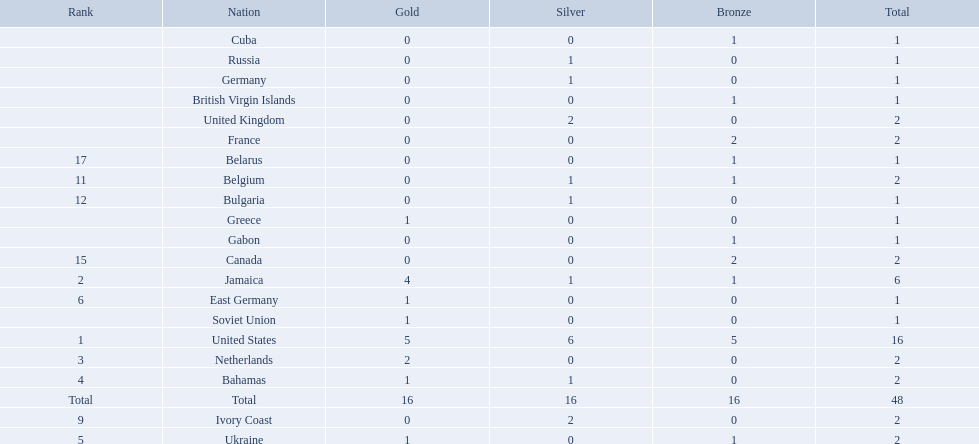What country won the most medals? United States. How many medals did the us win? 16. What is the most medals (after 16) that were won by a country? 6. Which country won 6 medals? Jamaica. 